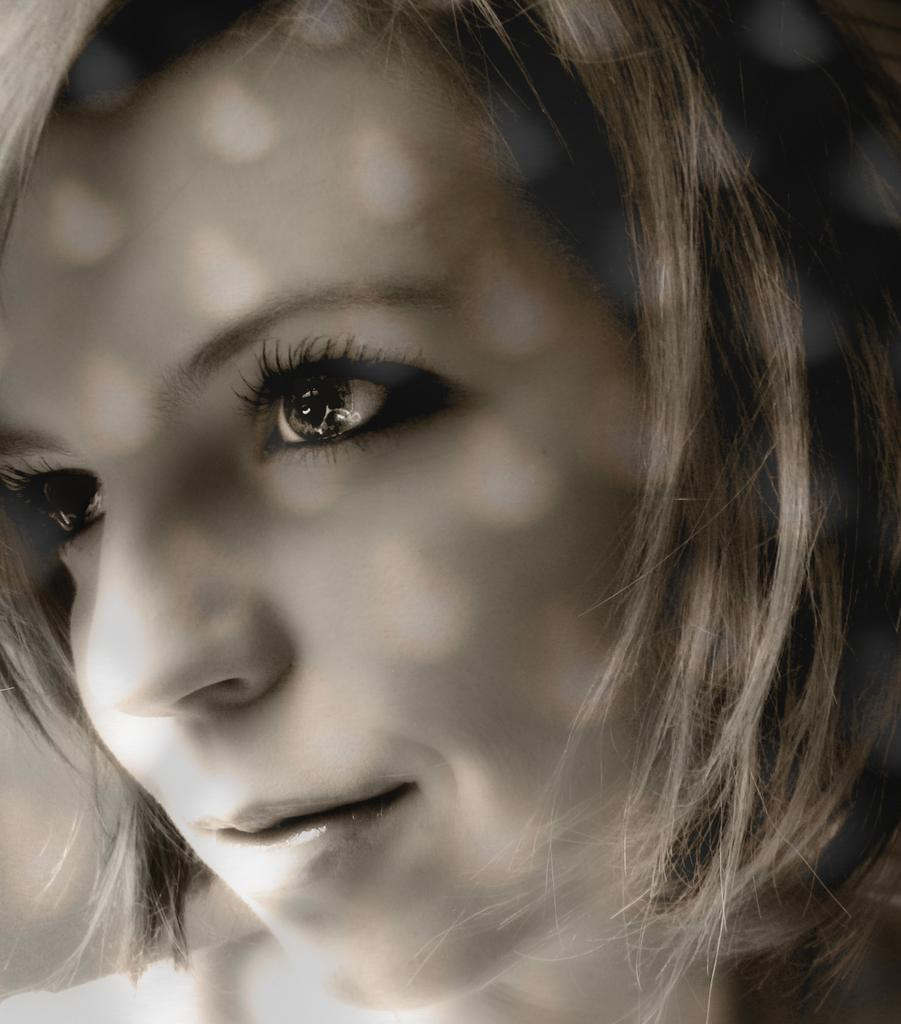What is the main subject of the image? There is a person in the image. What type of house is depicted in the background of the image? There is no house present in the image; it only features a person. What color is the vest worn by the person in the image? There is no information about the person's clothing, including a vest, in the provided facts. 